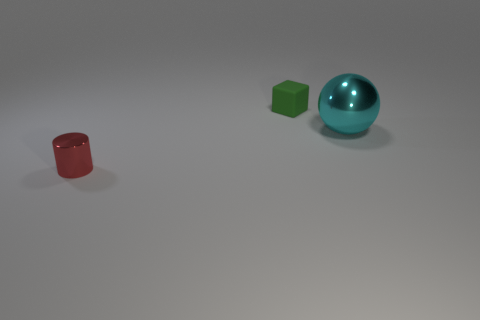Add 2 big metal cubes. How many objects exist? 5 Subtract 1 cubes. How many cubes are left? 0 Subtract all balls. How many objects are left? 2 Add 2 tiny gray metallic spheres. How many tiny gray metallic spheres exist? 2 Subtract 0 yellow blocks. How many objects are left? 3 Subtract all red blocks. Subtract all yellow cylinders. How many blocks are left? 1 Subtract all purple spheres. How many purple blocks are left? 0 Subtract all large green cylinders. Subtract all green rubber things. How many objects are left? 2 Add 2 cyan objects. How many cyan objects are left? 3 